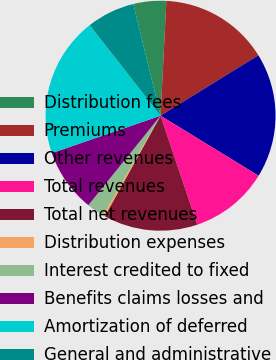Convert chart to OTSL. <chart><loc_0><loc_0><loc_500><loc_500><pie_chart><fcel>Distribution fees<fcel>Premiums<fcel>Other revenues<fcel>Total revenues<fcel>Total net revenues<fcel>Distribution expenses<fcel>Interest credited to fixed<fcel>Benefits claims losses and<fcel>Amortization of deferred<fcel>General and administrative<nl><fcel>4.61%<fcel>15.39%<fcel>17.55%<fcel>11.08%<fcel>13.23%<fcel>0.3%<fcel>2.45%<fcel>8.92%<fcel>19.7%<fcel>6.77%<nl></chart> 